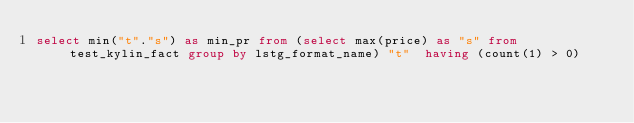<code> <loc_0><loc_0><loc_500><loc_500><_SQL_>select min("t"."s") as min_pr from (select max(price) as "s" from test_kylin_fact group by lstg_format_name) "t"  having (count(1) > 0)</code> 